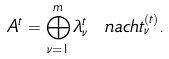<formula> <loc_0><loc_0><loc_500><loc_500>A ^ { t } = \bigoplus _ { \nu = 1 } ^ { m } \lambda _ { \nu } ^ { t } \ n a c h t _ { \nu } ^ { ( t ) } .</formula> 